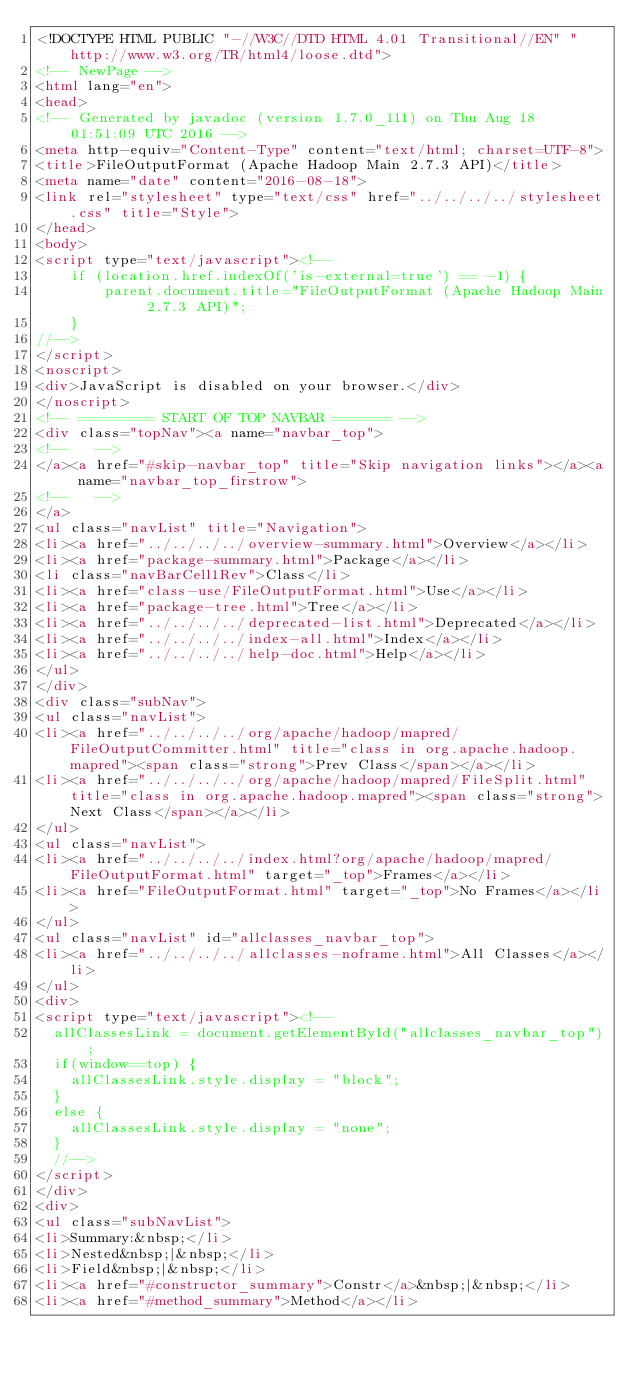<code> <loc_0><loc_0><loc_500><loc_500><_HTML_><!DOCTYPE HTML PUBLIC "-//W3C//DTD HTML 4.01 Transitional//EN" "http://www.w3.org/TR/html4/loose.dtd">
<!-- NewPage -->
<html lang="en">
<head>
<!-- Generated by javadoc (version 1.7.0_111) on Thu Aug 18 01:51:09 UTC 2016 -->
<meta http-equiv="Content-Type" content="text/html; charset=UTF-8">
<title>FileOutputFormat (Apache Hadoop Main 2.7.3 API)</title>
<meta name="date" content="2016-08-18">
<link rel="stylesheet" type="text/css" href="../../../../stylesheet.css" title="Style">
</head>
<body>
<script type="text/javascript"><!--
    if (location.href.indexOf('is-external=true') == -1) {
        parent.document.title="FileOutputFormat (Apache Hadoop Main 2.7.3 API)";
    }
//-->
</script>
<noscript>
<div>JavaScript is disabled on your browser.</div>
</noscript>
<!-- ========= START OF TOP NAVBAR ======= -->
<div class="topNav"><a name="navbar_top">
<!--   -->
</a><a href="#skip-navbar_top" title="Skip navigation links"></a><a name="navbar_top_firstrow">
<!--   -->
</a>
<ul class="navList" title="Navigation">
<li><a href="../../../../overview-summary.html">Overview</a></li>
<li><a href="package-summary.html">Package</a></li>
<li class="navBarCell1Rev">Class</li>
<li><a href="class-use/FileOutputFormat.html">Use</a></li>
<li><a href="package-tree.html">Tree</a></li>
<li><a href="../../../../deprecated-list.html">Deprecated</a></li>
<li><a href="../../../../index-all.html">Index</a></li>
<li><a href="../../../../help-doc.html">Help</a></li>
</ul>
</div>
<div class="subNav">
<ul class="navList">
<li><a href="../../../../org/apache/hadoop/mapred/FileOutputCommitter.html" title="class in org.apache.hadoop.mapred"><span class="strong">Prev Class</span></a></li>
<li><a href="../../../../org/apache/hadoop/mapred/FileSplit.html" title="class in org.apache.hadoop.mapred"><span class="strong">Next Class</span></a></li>
</ul>
<ul class="navList">
<li><a href="../../../../index.html?org/apache/hadoop/mapred/FileOutputFormat.html" target="_top">Frames</a></li>
<li><a href="FileOutputFormat.html" target="_top">No Frames</a></li>
</ul>
<ul class="navList" id="allclasses_navbar_top">
<li><a href="../../../../allclasses-noframe.html">All Classes</a></li>
</ul>
<div>
<script type="text/javascript"><!--
  allClassesLink = document.getElementById("allclasses_navbar_top");
  if(window==top) {
    allClassesLink.style.display = "block";
  }
  else {
    allClassesLink.style.display = "none";
  }
  //-->
</script>
</div>
<div>
<ul class="subNavList">
<li>Summary:&nbsp;</li>
<li>Nested&nbsp;|&nbsp;</li>
<li>Field&nbsp;|&nbsp;</li>
<li><a href="#constructor_summary">Constr</a>&nbsp;|&nbsp;</li>
<li><a href="#method_summary">Method</a></li></code> 